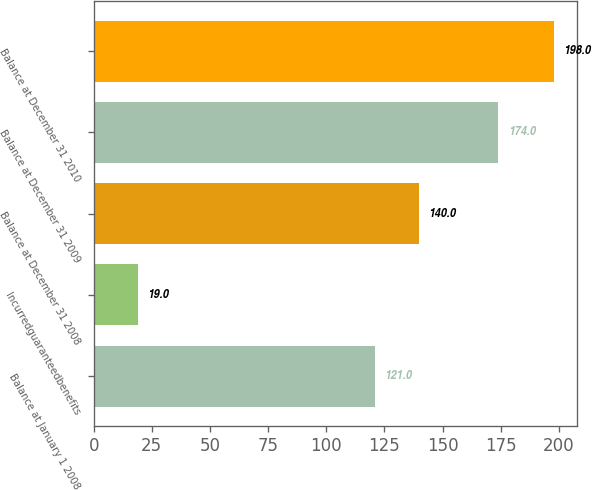Convert chart. <chart><loc_0><loc_0><loc_500><loc_500><bar_chart><fcel>Balance at January 1 2008<fcel>Incurredguaranteedbenefits<fcel>Balance at December 31 2008<fcel>Balance at December 31 2009<fcel>Balance at December 31 2010<nl><fcel>121<fcel>19<fcel>140<fcel>174<fcel>198<nl></chart> 